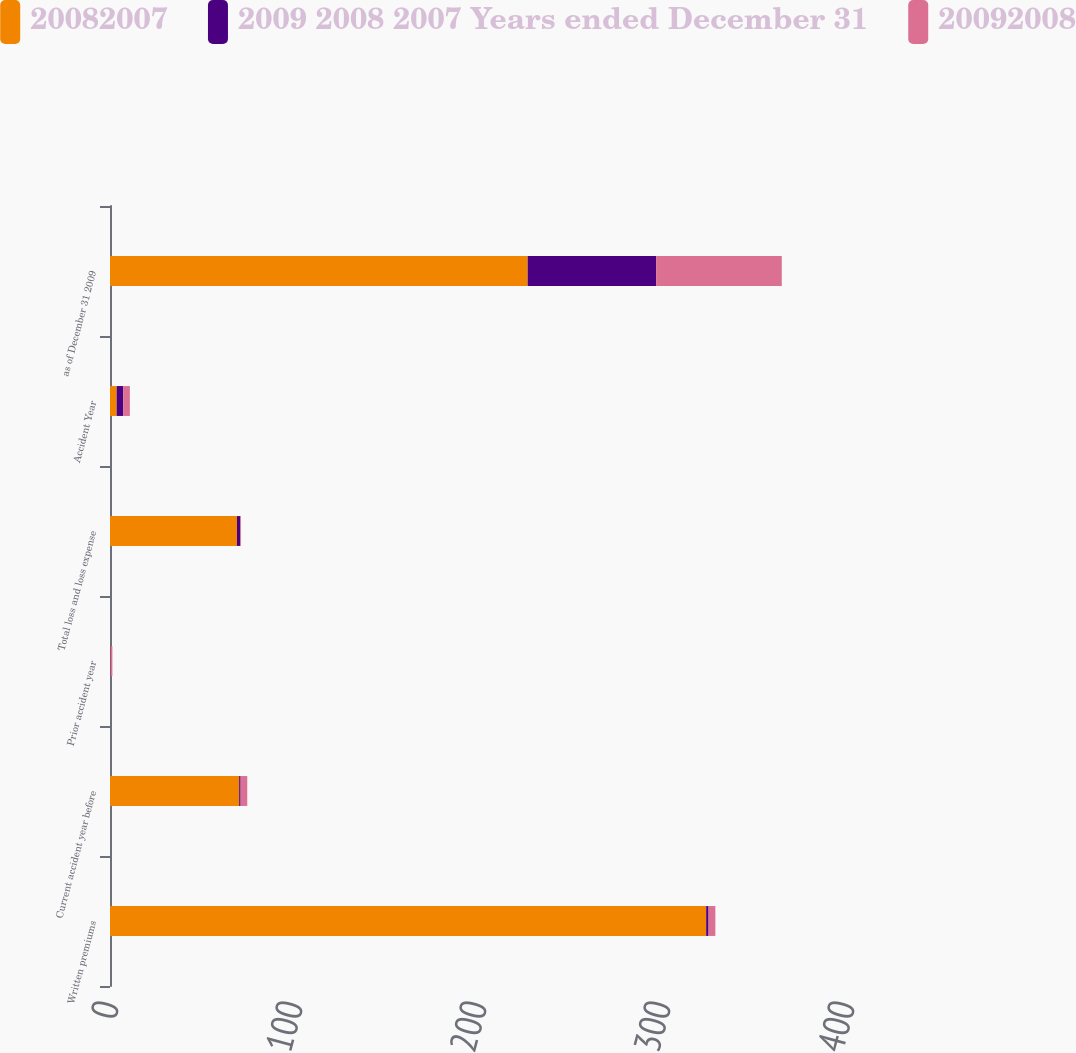Convert chart. <chart><loc_0><loc_0><loc_500><loc_500><stacked_bar_chart><ecel><fcel>Written premiums<fcel>Current accident year before<fcel>Prior accident year<fcel>Total loss and loss expense<fcel>Accident Year<fcel>as of December 31 2009<nl><fcel>20082007<fcel>324<fcel>70.2<fcel>0.2<fcel>69<fcel>3.6<fcel>227<nl><fcel>2009 2008 2007 Years ended December 31<fcel>1.3<fcel>0.8<fcel>0.2<fcel>1.8<fcel>3.6<fcel>69.8<nl><fcel>20092008<fcel>3.7<fcel>3.6<fcel>0.9<fcel>0.4<fcel>3.6<fcel>68.3<nl></chart> 